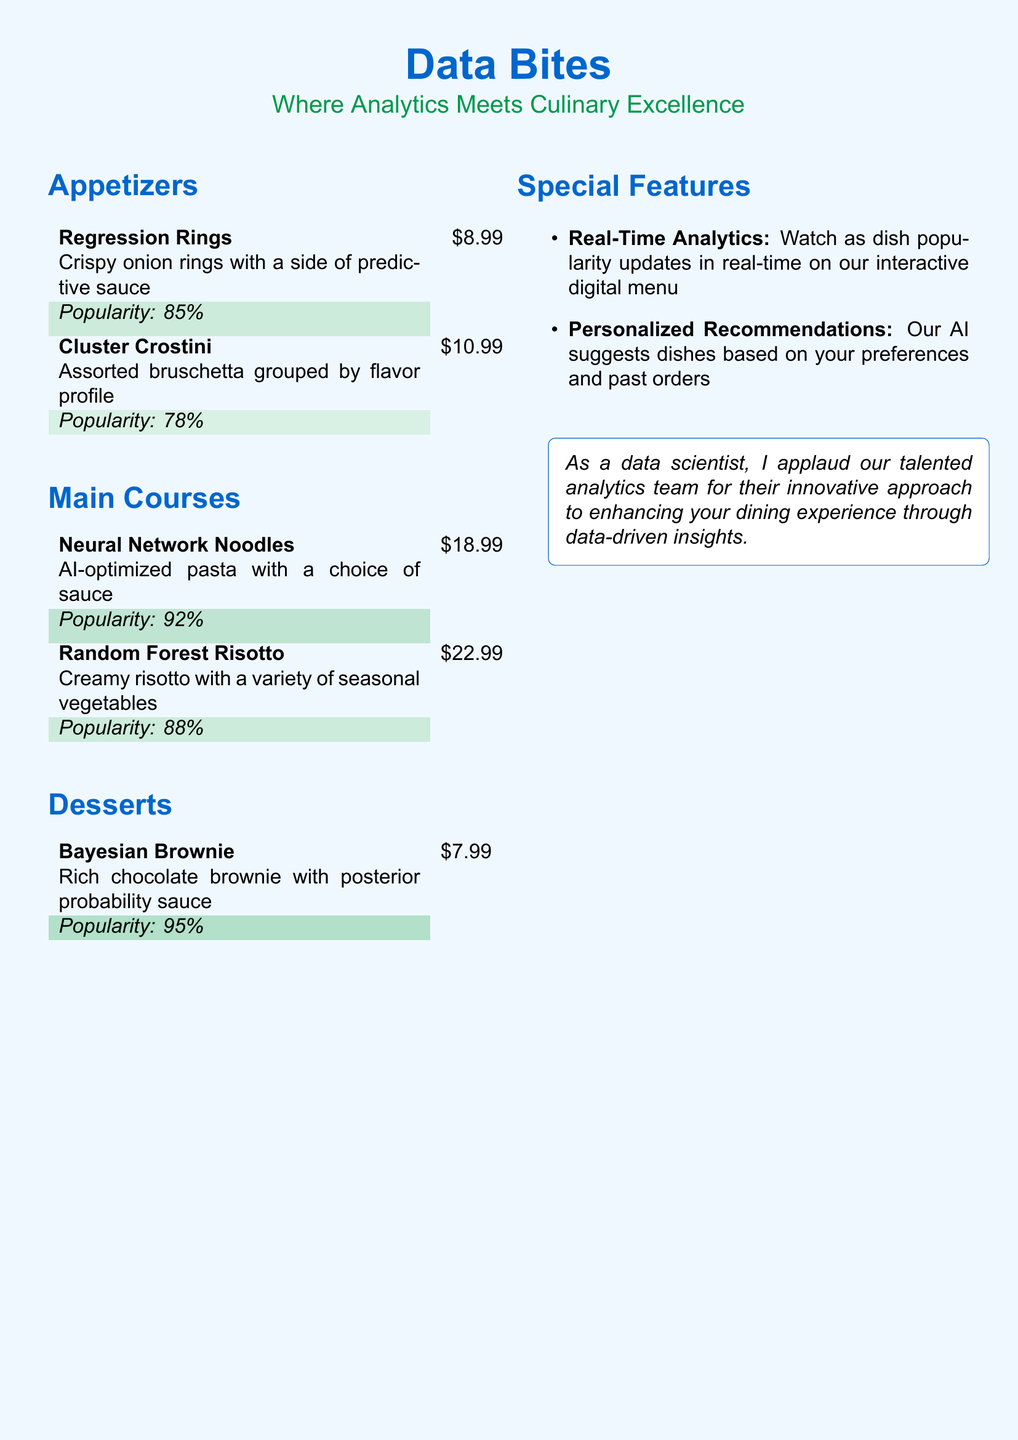What is the price of Regression Rings? The price is directly listed in the menu under the appetizers section.
Answer: $8.99 What is the popularity percentage of Neural Network Noodles? The popularity percentage is indicated next to the dish name in the main courses section.
Answer: 92% How many appetizers are listed in the menu? The number of appetizers can be counted in the appetizers section of the document.
Answer: 2 Which dessert has the highest popularity? The popularity percentages of the desserts are noted, allowing for comparison.
Answer: Bayesian Brownie What type of recommendations does the menu offer? The special features of the menu mention the kind of recommendations provided to guests.
Answer: Personalized Recommendations What is the main theme of the restaurant? The title and subtitle convey the overall theme of the restaurant.
Answer: Where Analytics Meets Culinary Excellence What dish is made with seasonal vegetables? The details under the main courses indicate which dish contains seasonal vegetables.
Answer: Random Forest Risotto Which dish is associated with posterior probability sauce? The description of the dish in the desserts section specifies its unique sauce.
Answer: Bayesian Brownie What feature allows for real-time updates on dish popularity? The special features section explicitly mentions this capability.
Answer: Real-Time Analytics 